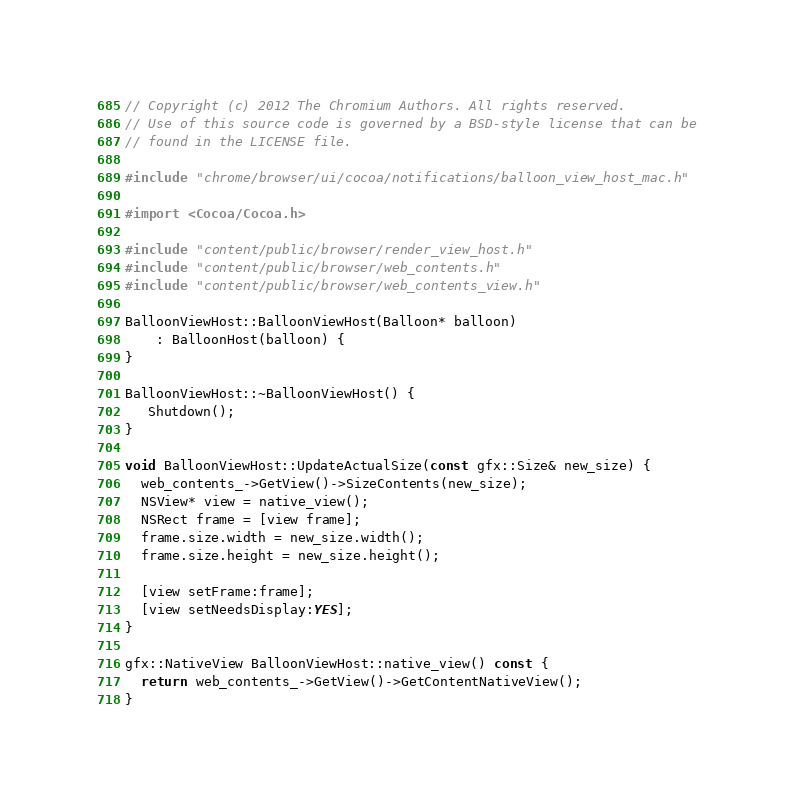Convert code to text. <code><loc_0><loc_0><loc_500><loc_500><_ObjectiveC_>// Copyright (c) 2012 The Chromium Authors. All rights reserved.
// Use of this source code is governed by a BSD-style license that can be
// found in the LICENSE file.

#include "chrome/browser/ui/cocoa/notifications/balloon_view_host_mac.h"

#import <Cocoa/Cocoa.h>

#include "content/public/browser/render_view_host.h"
#include "content/public/browser/web_contents.h"
#include "content/public/browser/web_contents_view.h"

BalloonViewHost::BalloonViewHost(Balloon* balloon)
    : BalloonHost(balloon) {
}

BalloonViewHost::~BalloonViewHost() {
   Shutdown();
}

void BalloonViewHost::UpdateActualSize(const gfx::Size& new_size) {
  web_contents_->GetView()->SizeContents(new_size);
  NSView* view = native_view();
  NSRect frame = [view frame];
  frame.size.width = new_size.width();
  frame.size.height = new_size.height();

  [view setFrame:frame];
  [view setNeedsDisplay:YES];
}

gfx::NativeView BalloonViewHost::native_view() const {
  return web_contents_->GetView()->GetContentNativeView();
}
</code> 